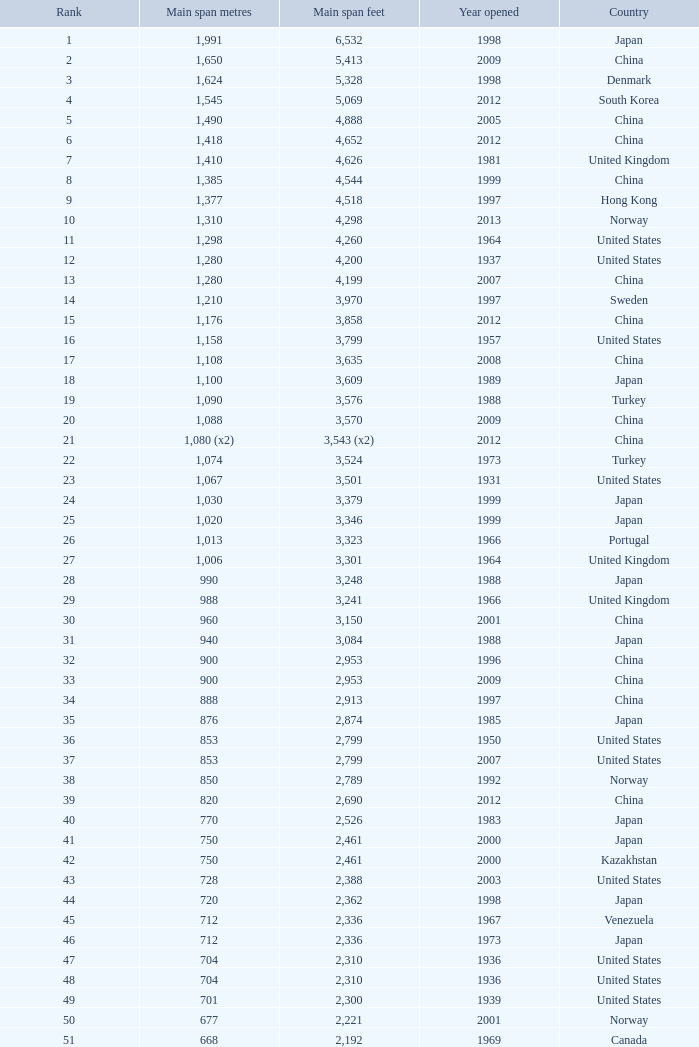What is the main span feet from opening year of 1936 in the United States with a rank greater than 47 and 421 main span metres? 1381.0. 